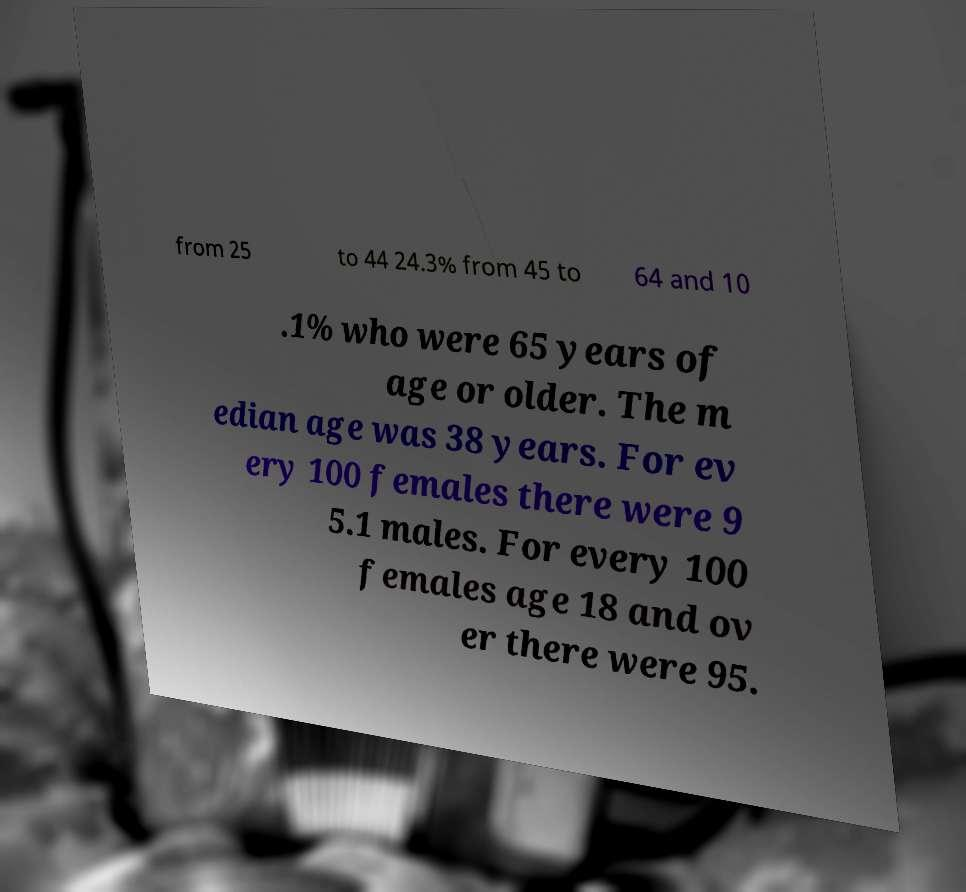Could you extract and type out the text from this image? from 25 to 44 24.3% from 45 to 64 and 10 .1% who were 65 years of age or older. The m edian age was 38 years. For ev ery 100 females there were 9 5.1 males. For every 100 females age 18 and ov er there were 95. 